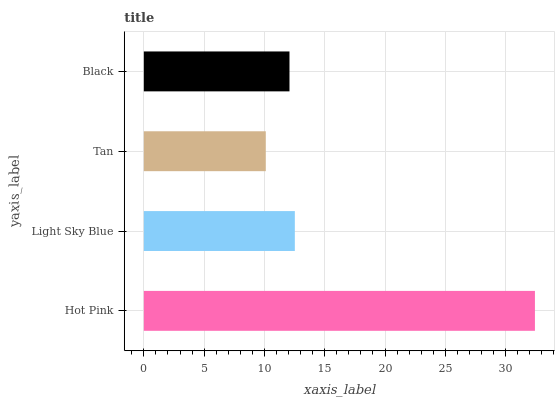Is Tan the minimum?
Answer yes or no. Yes. Is Hot Pink the maximum?
Answer yes or no. Yes. Is Light Sky Blue the minimum?
Answer yes or no. No. Is Light Sky Blue the maximum?
Answer yes or no. No. Is Hot Pink greater than Light Sky Blue?
Answer yes or no. Yes. Is Light Sky Blue less than Hot Pink?
Answer yes or no. Yes. Is Light Sky Blue greater than Hot Pink?
Answer yes or no. No. Is Hot Pink less than Light Sky Blue?
Answer yes or no. No. Is Light Sky Blue the high median?
Answer yes or no. Yes. Is Black the low median?
Answer yes or no. Yes. Is Black the high median?
Answer yes or no. No. Is Hot Pink the low median?
Answer yes or no. No. 